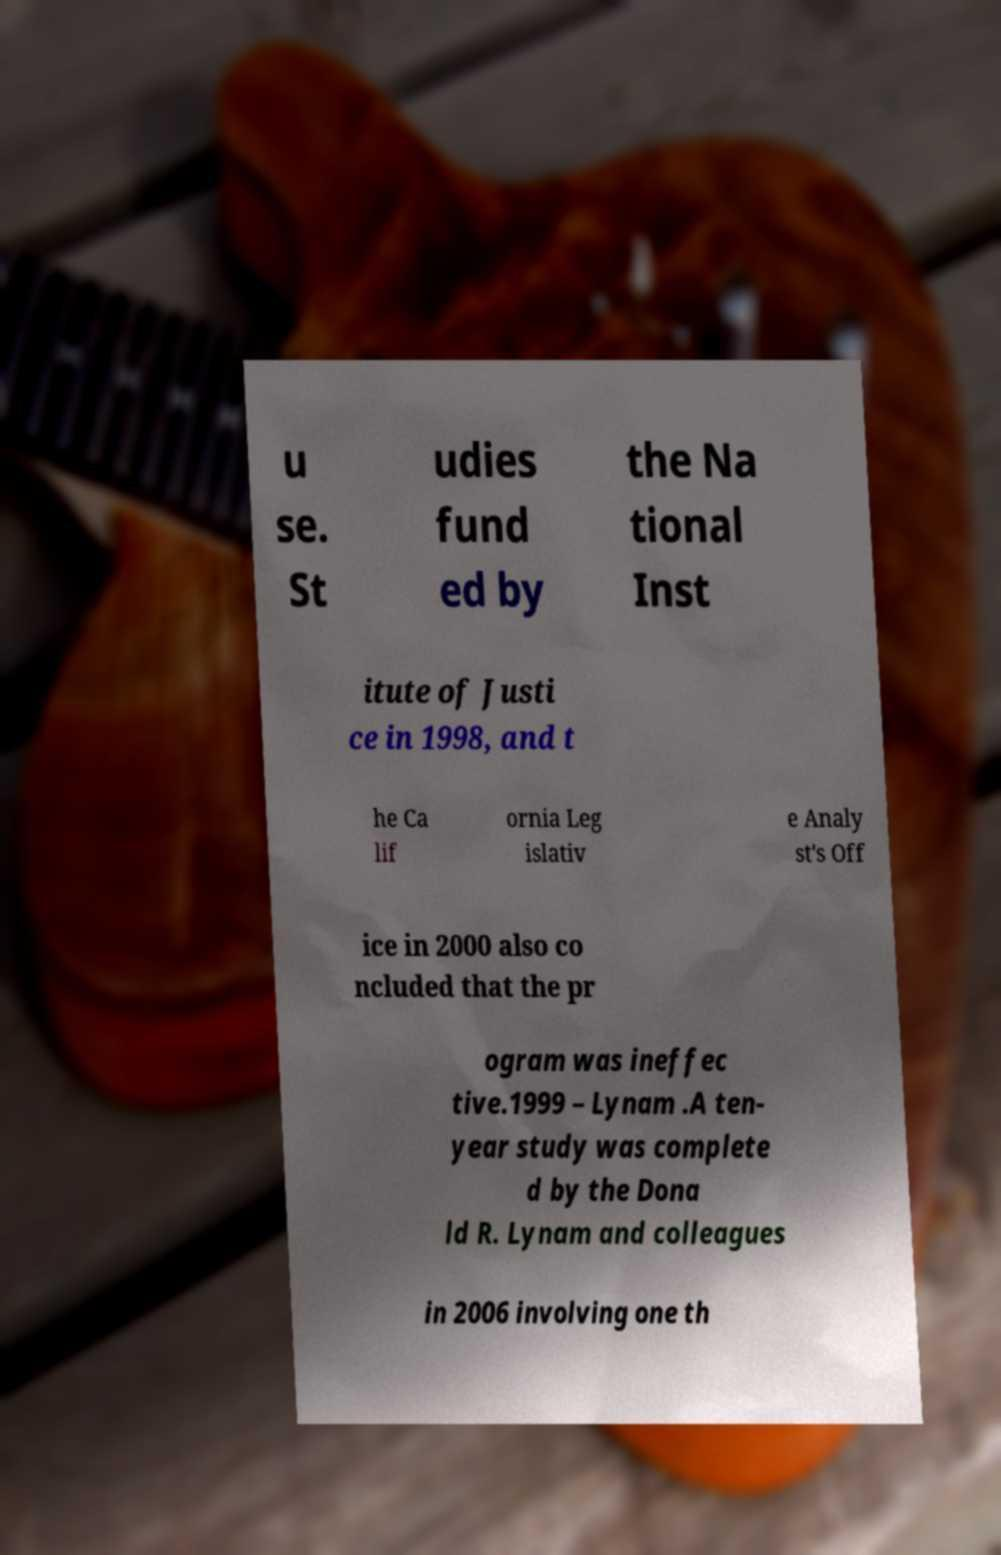What messages or text are displayed in this image? I need them in a readable, typed format. u se. St udies fund ed by the Na tional Inst itute of Justi ce in 1998, and t he Ca lif ornia Leg islativ e Analy st's Off ice in 2000 also co ncluded that the pr ogram was ineffec tive.1999 – Lynam .A ten- year study was complete d by the Dona ld R. Lynam and colleagues in 2006 involving one th 